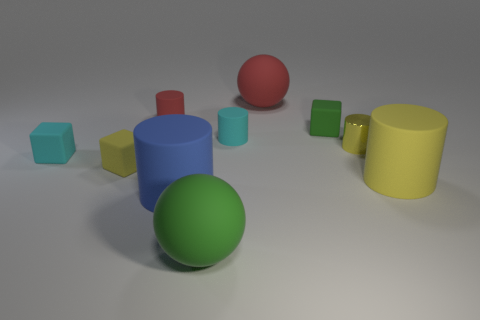Subtract all gray cylinders. Subtract all purple spheres. How many cylinders are left? 5 Subtract all balls. How many objects are left? 8 Subtract 0 yellow balls. How many objects are left? 10 Subtract all small yellow spheres. Subtract all green rubber objects. How many objects are left? 8 Add 1 big blue rubber things. How many big blue rubber things are left? 2 Add 7 large red rubber objects. How many large red rubber objects exist? 8 